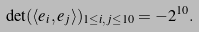Convert formula to latex. <formula><loc_0><loc_0><loc_500><loc_500>\det ( \langle { e } _ { i } , { e } _ { j } \rangle ) _ { 1 \leq i , j \leq 1 0 } = - 2 ^ { 1 0 } .</formula> 